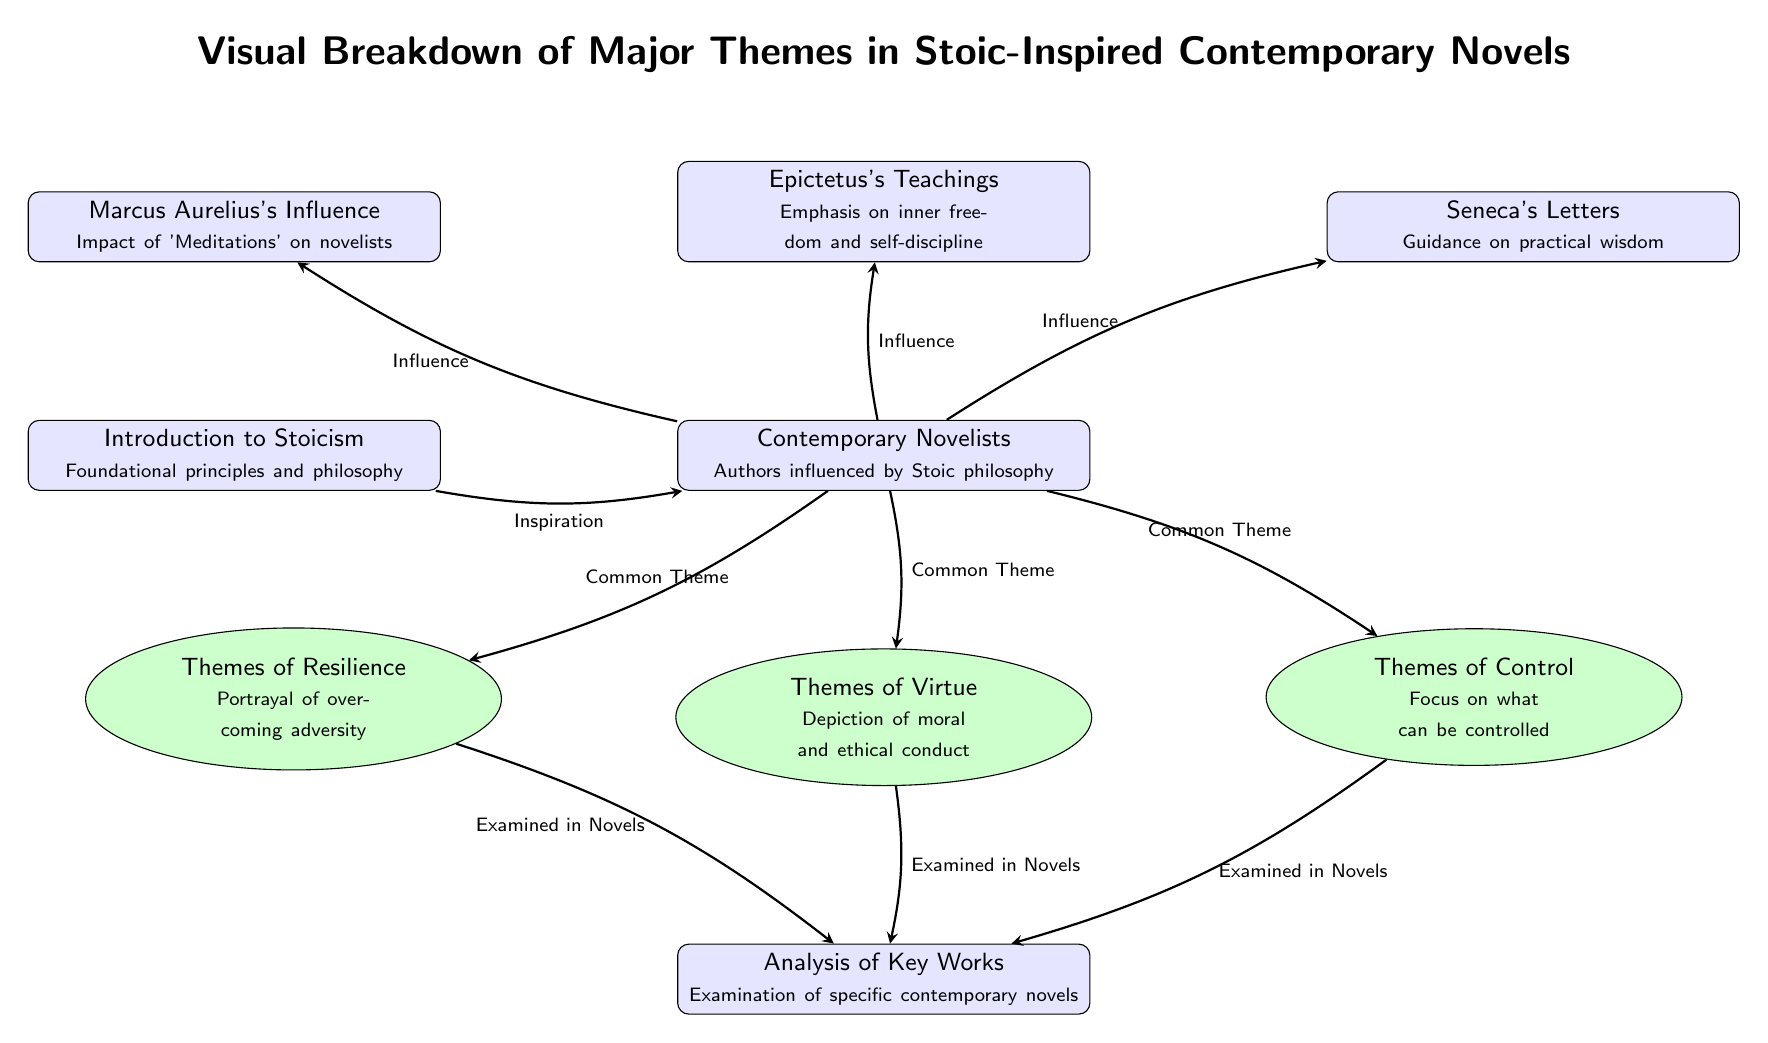What's the title of the diagram? The title of the diagram, as indicated at the top, is "Visual Breakdown of Major Themes in Stoic-Inspired Contemporary Novels".
Answer: Visual Breakdown of Major Themes in Stoic-Inspired Contemporary Novels How many contemporary novelists are depicted? The node labeled "Contemporary Novelists" indicates that this is the primary focus of the diagram, but the exact number of individual novelists is not specified, hence it remains at one representation.
Answer: One Name one influence on contemporary novelists related to Stoicism. The diagram lists three influences on contemporary novelists, which are Marcus Aurelius, Epictetus, and Seneca, as indicated by the arrows connecting the box labeled "Contemporary Novelists" to these three nodes.
Answer: Marcus Aurelius What is one major theme related to Stoicism depicted in the diagram? The diagram identifies three major themes related to Stoicism that are common among contemporary novels: Resilience, Virtue, and Control, as shown by the arrows connecting these themes to the "Contemporary Novelists" node.
Answer: Resilience Which theme examines the overcoming of adversity? The node labeled "Themes of Resilience" explicitly details the portrayal of overcoming adversity as a significant theme in Stoic-inspired contemporary novels.
Answer: Themes of Resilience How do contemporary novelists show that virtue is a common theme? The diagram shows that the influence on contemporary novelists includes multiple Stoic principles, and the common theme of virtue is directly connected through the arrow labeled "Common Theme", indicating that virtue is examined in their works.
Answer: Through the arrow labeled "Common Theme" How is the theme of control represented in relation to analysis of key works? The diagram draws a direct connection between the "Themes of Control" node and the "Analysis of Key Works" node, indicating that the examination of control as a theme is specifically analyzed in various contemporary novels.
Answer: By the arrow labeled "Examined in Novels" 